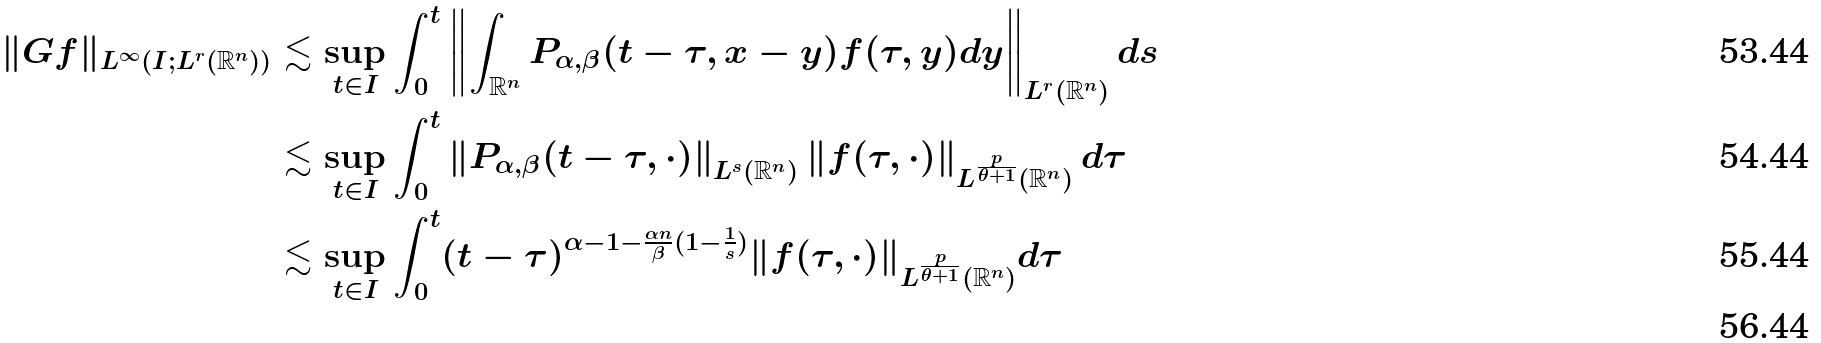Convert formula to latex. <formula><loc_0><loc_0><loc_500><loc_500>\| G f \| _ { L ^ { \infty } ( I ; L ^ { r } ( \mathbb { R } ^ { n } ) ) } & \lesssim \sup _ { t \in I } \int _ { 0 } ^ { t } \left \| \int _ { \mathbb { R } ^ { n } } P _ { \alpha , \beta } ( t - \tau , x - y ) f ( \tau , y ) d y \right \| _ { L ^ { r } ( \mathbb { R } ^ { n } ) } d s \\ & \lesssim \sup _ { t \in I } \int _ { 0 } ^ { t } \left \| P _ { \alpha , \beta } ( t - \tau , \cdot ) \right \| _ { L ^ { s } ( \mathbb { R } ^ { n } ) } \left \| f ( \tau , \cdot ) \right \| _ { L ^ { \frac { p } { \theta + 1 } } ( \mathbb { R } ^ { n } ) } d \tau \\ & \lesssim \sup _ { t \in I } \int _ { 0 } ^ { t } ( t - \tau ) ^ { \alpha - 1 - \frac { \alpha n } { \beta } ( 1 - \frac { 1 } { s } ) } \| f ( \tau , \cdot ) \| _ { L ^ { \frac { p } { \theta + 1 } } ( \mathbb { R } ^ { n } ) } d \tau \\</formula> 